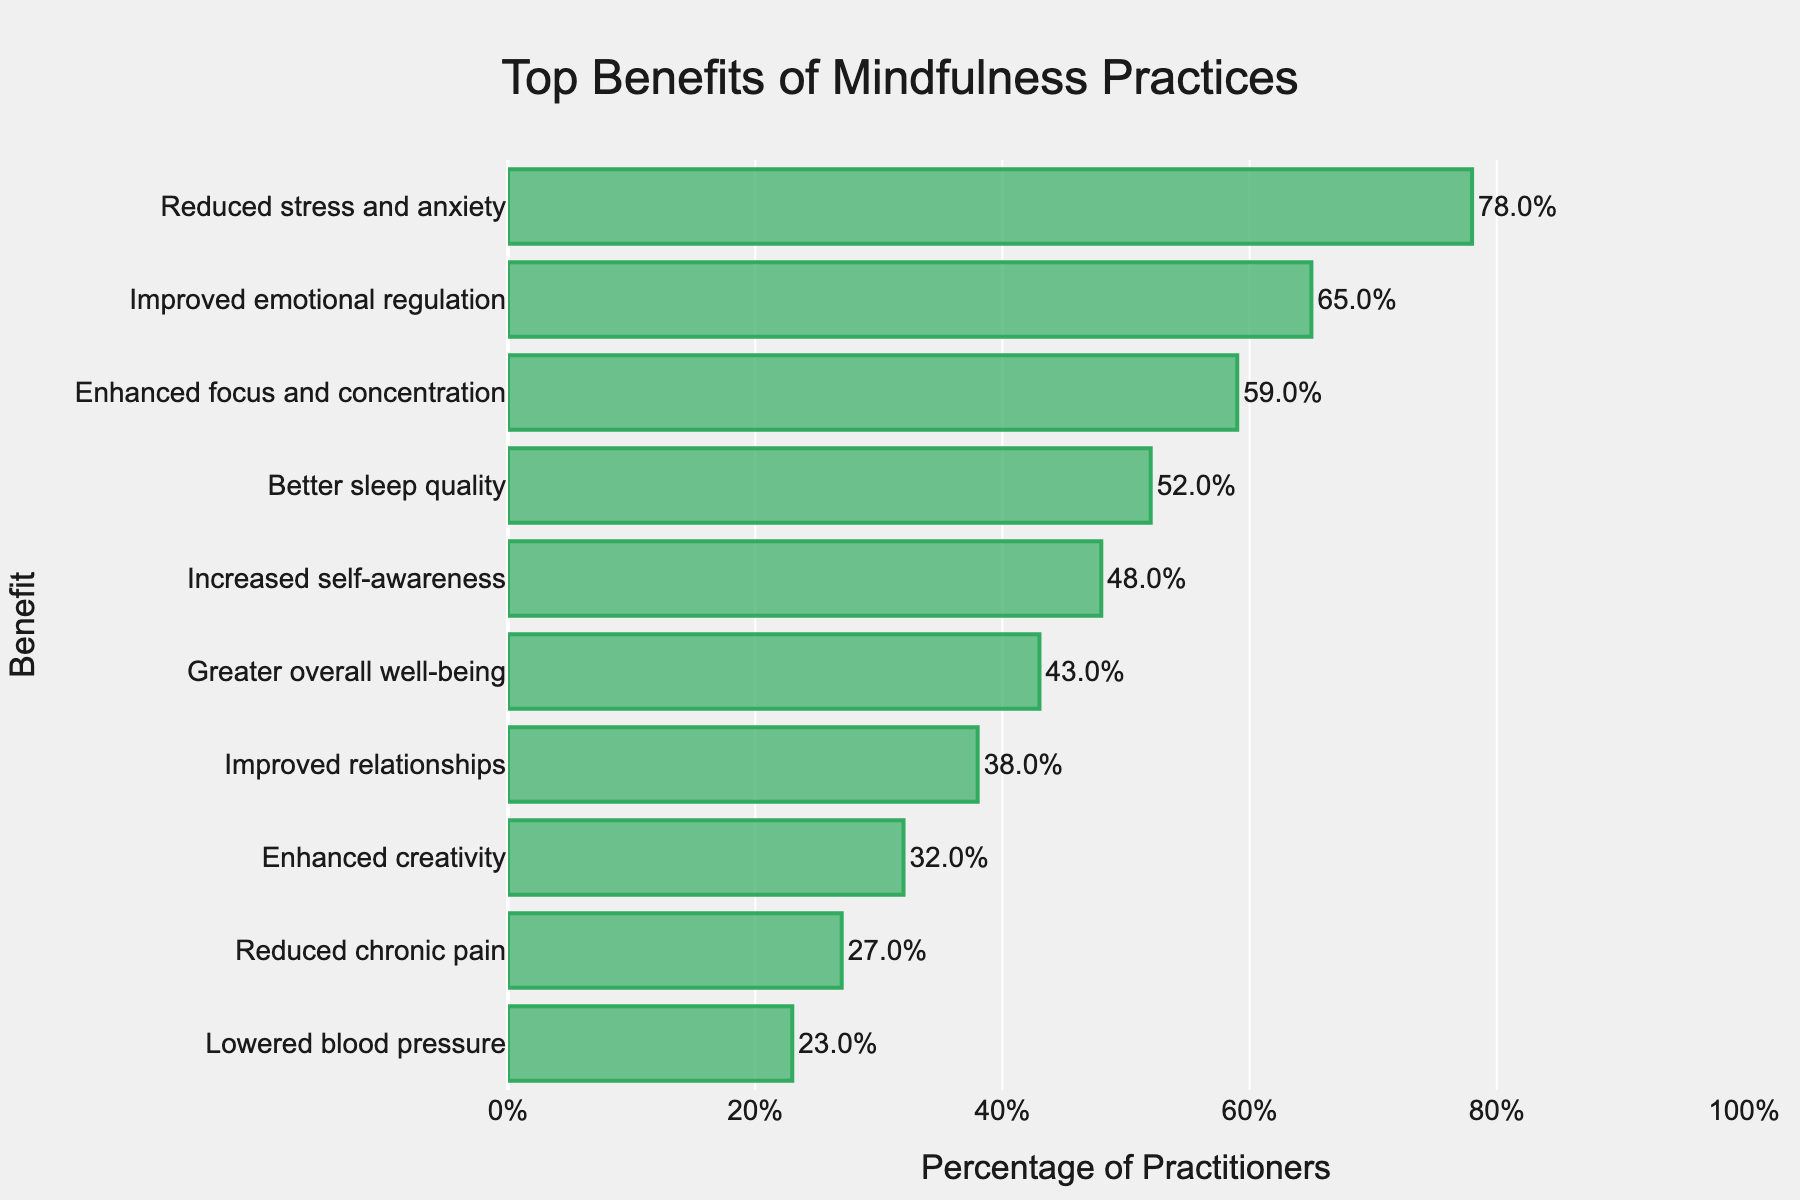What is the most commonly reported benefit of mindfulness practices? Look at the topmost bar on the chart, which indicates the benefit experienced by the highest percentage of practitioners.
Answer: Reduced stress and anxiety Which benefit has a higher percentage, better sleep quality or increased self-awareness? Compare the lengths/positions of the bars representing better sleep quality and increased self-awareness.
Answer: Better sleep quality What percentage of practitioners experienced enhanced focus and concentration? Identify the bar labeled "Enhanced focus and concentration" and read the corresponding percentage value.
Answer: 59% How much higher is the percentage of practitioners reporting improved emotional regulation than those reporting reduced chronic pain? Subtract the percentage of practitioners reporting reduced chronic pain (27%) from those reporting improved emotional regulation (65%).
Answer: 38% Between reduced stress and anxiety and improved relationships, which benefit is experienced by a smaller percentage of practitioners, and by how much? Compare the percentages for reduced stress and anxiety (78%) and improved relationships (38%), and calculate the difference.
Answer: Improved relationships, by 40% Rank the top three benefits of mindfulness practices based on the percentage of practitioners experiencing them. List the top three bars in descending order according to their percentage values.
Answer: Reduced stress and anxiety, Improved emotional regulation, Enhanced focus and concentration How many benefits have a percentage of 50% or higher? Count the number of bars with percentage values of 50% or higher.
Answer: 4 What is the combined percentage of practitioners experiencing enhanced creativity and lowered blood pressure? Add the percentages for enhanced creativity (32%) and lowered blood pressure (23%).
Answer: 55% Which benefit has the shortest bar in the chart? Identify the bottommost bar in the chart, which is the shortest in length.
Answer: Lowered blood pressure By how much does better sleep quality exceed greater overall well-being in terms of percentage? Subtract the percentage of practitioners reporting greater overall well-being (43%) from better sleep quality (52%).
Answer: 9% 